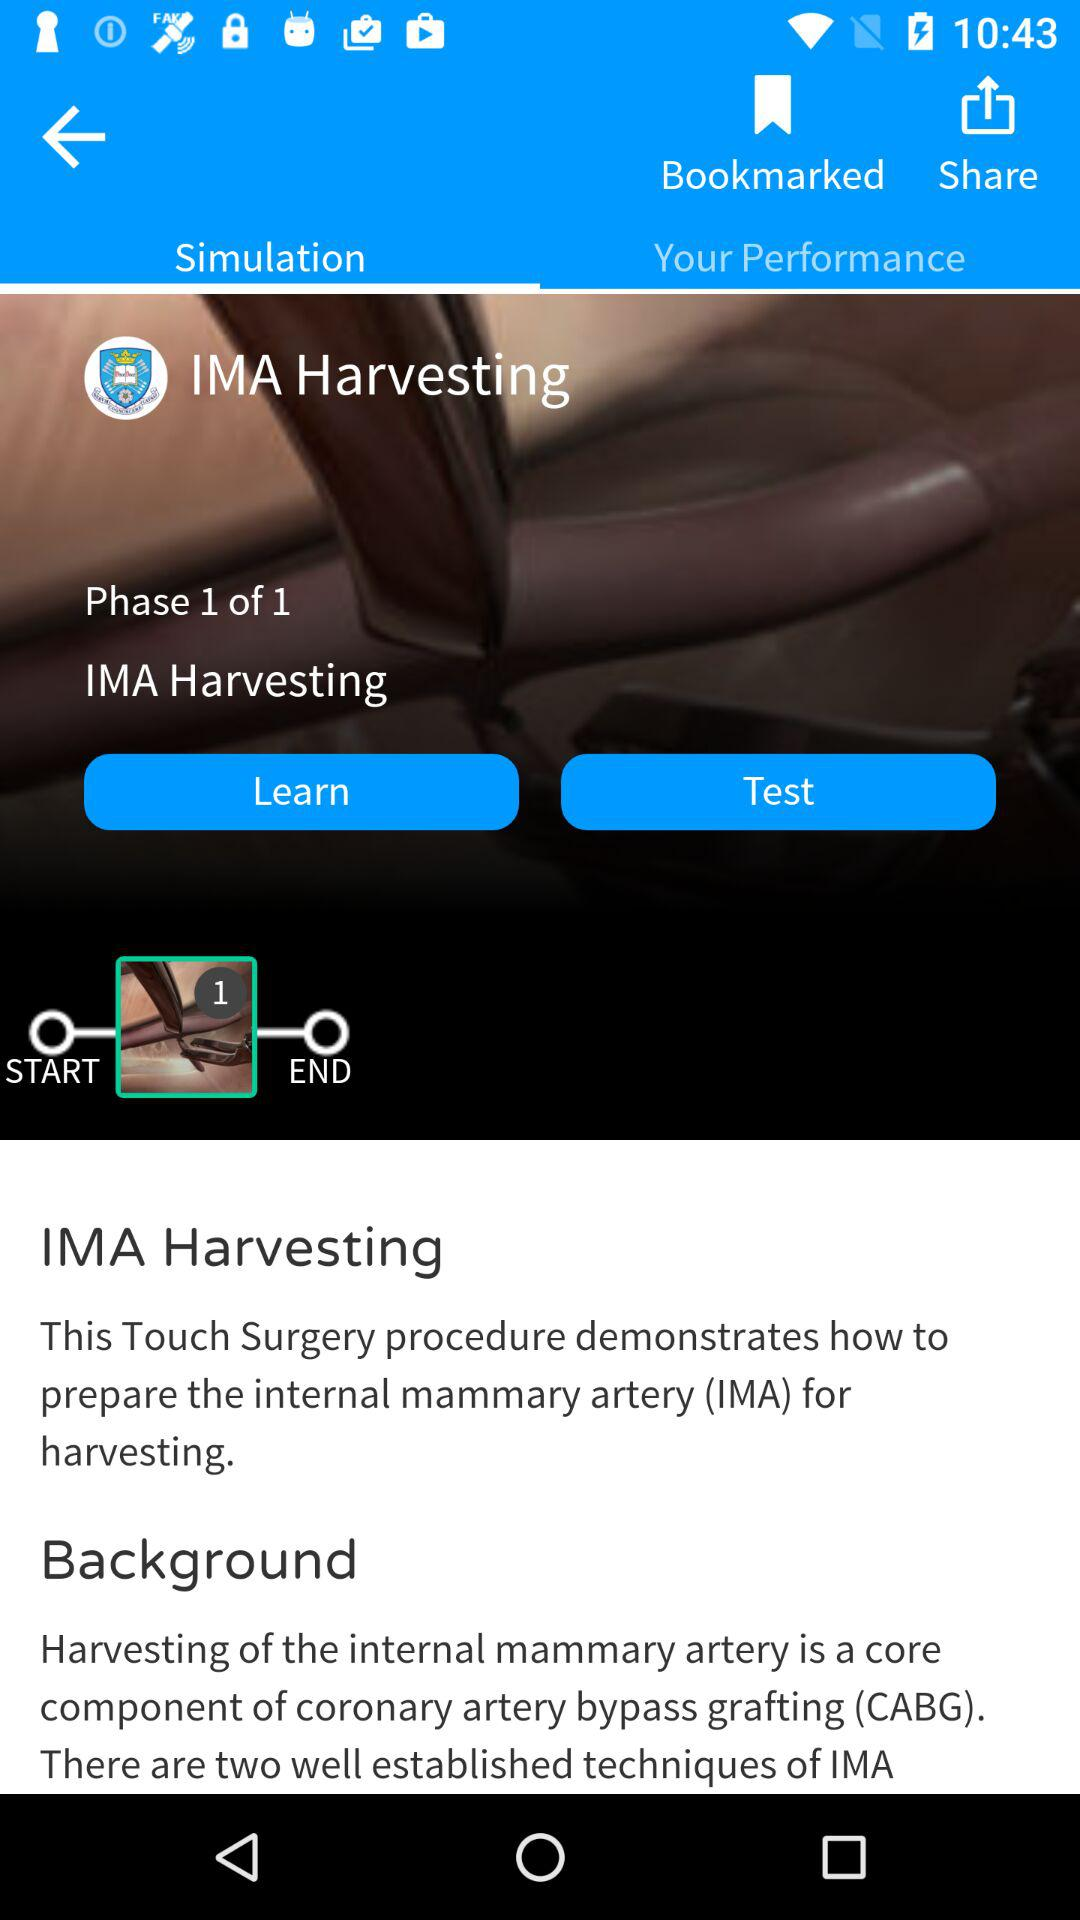Which tab is selected? The selected tab is "Simulation". 